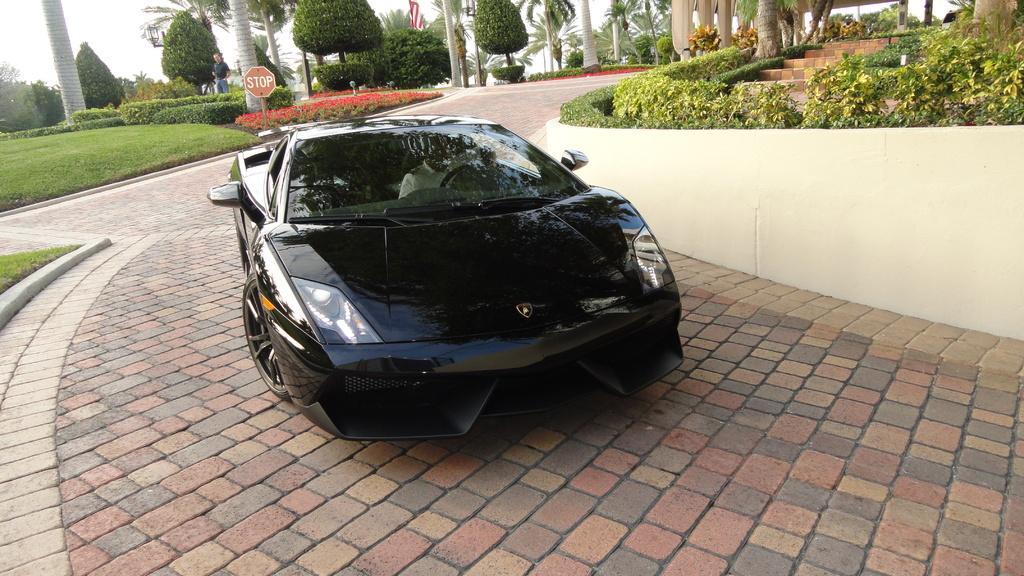How would you summarize this image in a sentence or two? This picture shows a black color sports car and we see trees and plants and a sign board and we see a human standing and a flag and we see grass on the ground and a cloudy Sky. 